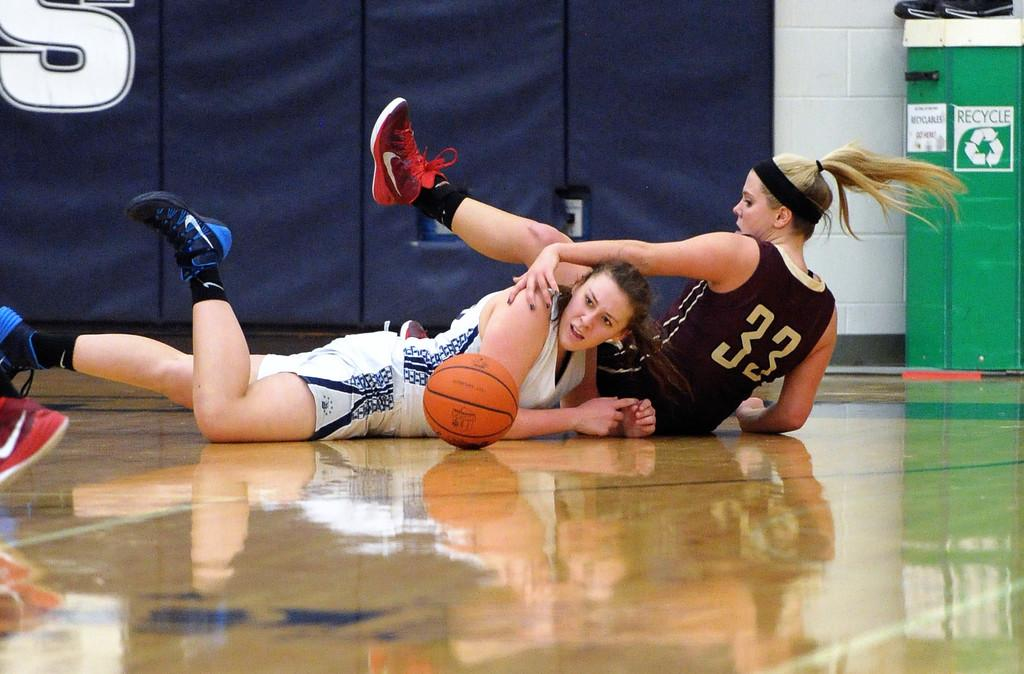<image>
Create a compact narrative representing the image presented. Female basketball player wearing number 33 diving for the ball. 